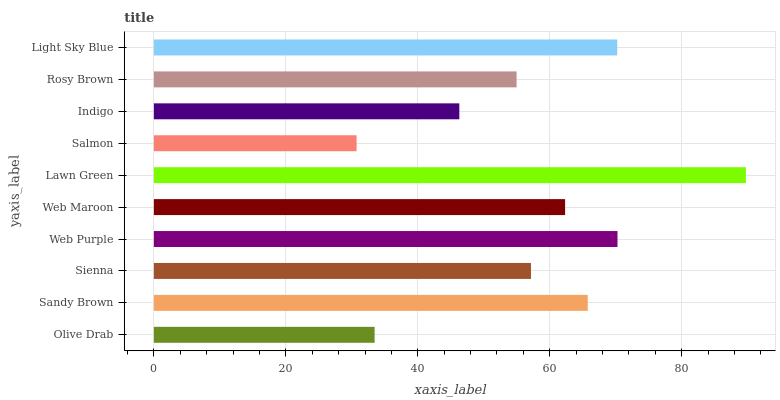Is Salmon the minimum?
Answer yes or no. Yes. Is Lawn Green the maximum?
Answer yes or no. Yes. Is Sandy Brown the minimum?
Answer yes or no. No. Is Sandy Brown the maximum?
Answer yes or no. No. Is Sandy Brown greater than Olive Drab?
Answer yes or no. Yes. Is Olive Drab less than Sandy Brown?
Answer yes or no. Yes. Is Olive Drab greater than Sandy Brown?
Answer yes or no. No. Is Sandy Brown less than Olive Drab?
Answer yes or no. No. Is Web Maroon the high median?
Answer yes or no. Yes. Is Sienna the low median?
Answer yes or no. Yes. Is Olive Drab the high median?
Answer yes or no. No. Is Olive Drab the low median?
Answer yes or no. No. 